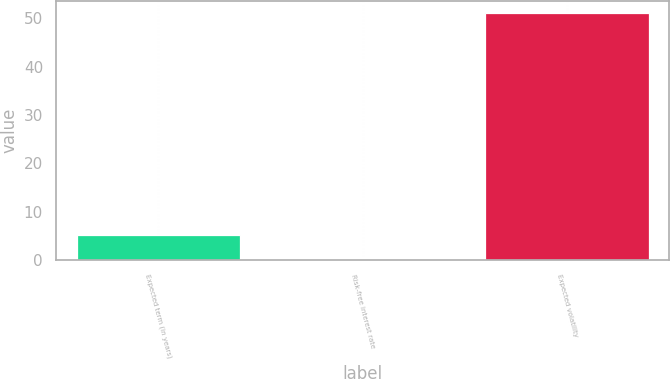<chart> <loc_0><loc_0><loc_500><loc_500><bar_chart><fcel>Expected term (in years)<fcel>Risk-free interest rate<fcel>Expected volatility<nl><fcel>5.19<fcel>0.1<fcel>51<nl></chart> 